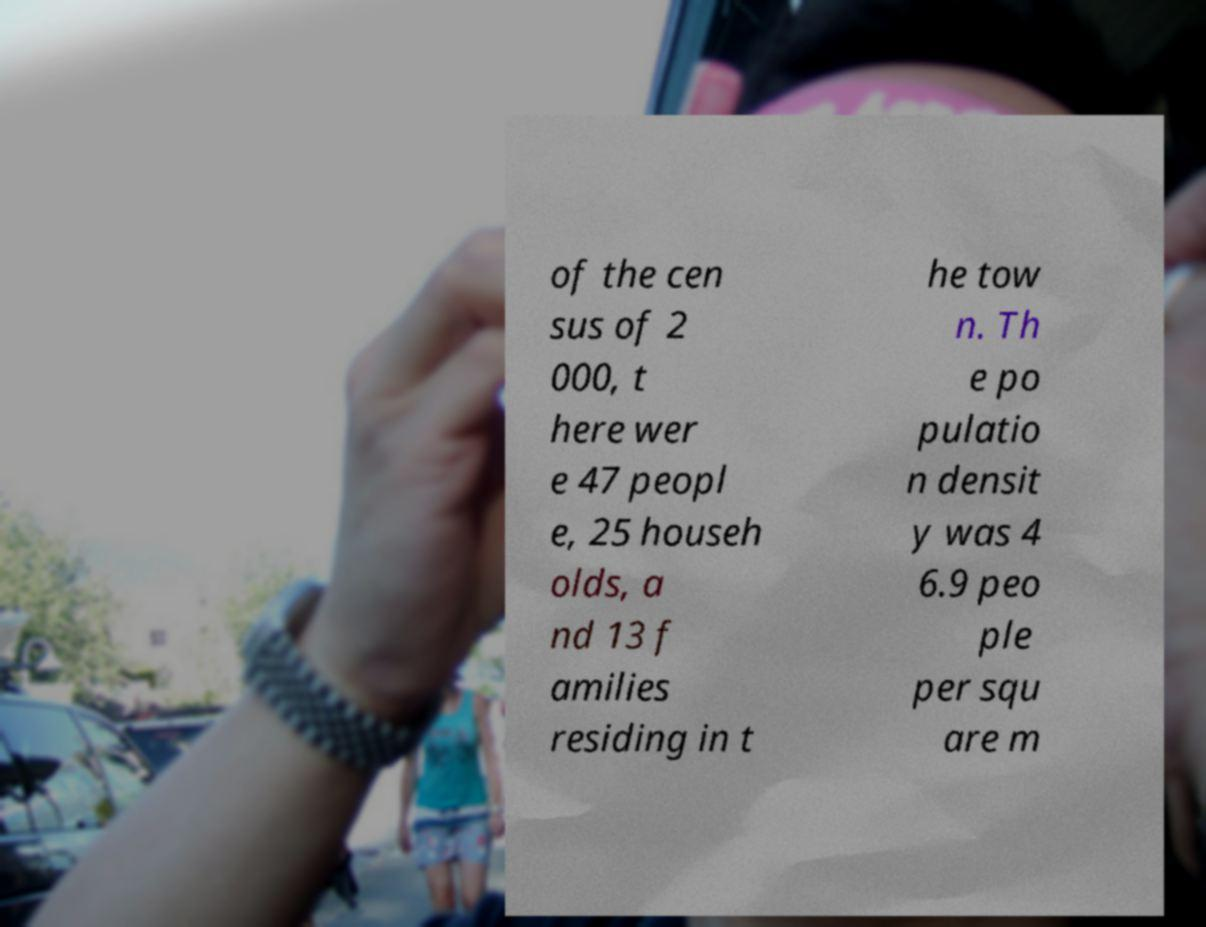Could you extract and type out the text from this image? of the cen sus of 2 000, t here wer e 47 peopl e, 25 househ olds, a nd 13 f amilies residing in t he tow n. Th e po pulatio n densit y was 4 6.9 peo ple per squ are m 